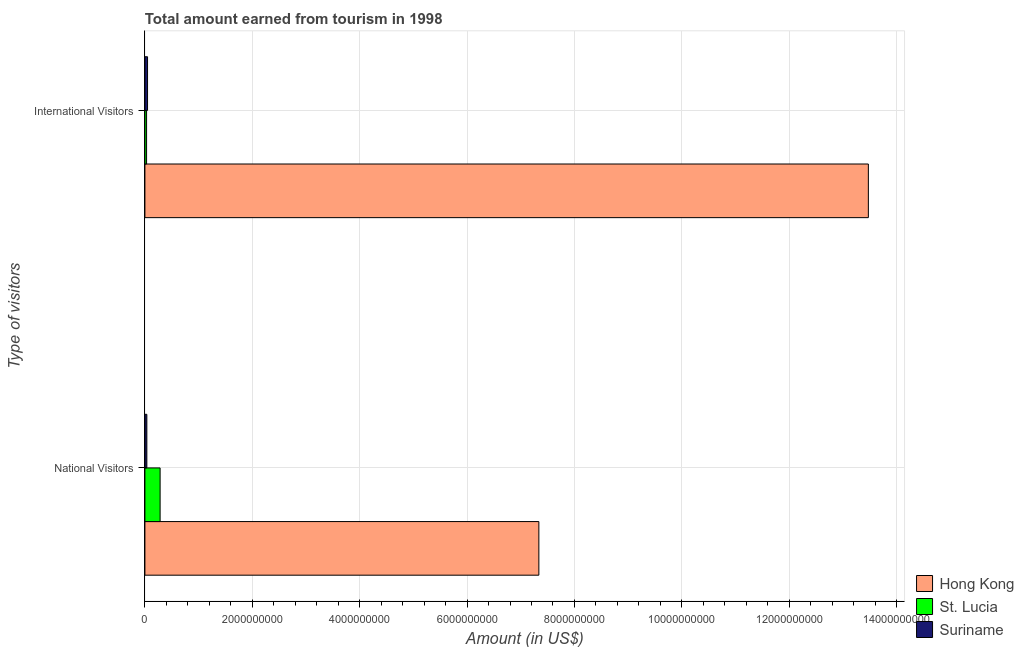Are the number of bars per tick equal to the number of legend labels?
Make the answer very short. Yes. How many bars are there on the 1st tick from the bottom?
Provide a short and direct response. 3. What is the label of the 2nd group of bars from the top?
Provide a succinct answer. National Visitors. What is the amount earned from national visitors in St. Lucia?
Keep it short and to the point. 2.83e+08. Across all countries, what is the maximum amount earned from international visitors?
Your answer should be compact. 1.35e+1. Across all countries, what is the minimum amount earned from national visitors?
Offer a very short reply. 3.60e+07. In which country was the amount earned from national visitors maximum?
Provide a short and direct response. Hong Kong. In which country was the amount earned from national visitors minimum?
Keep it short and to the point. Suriname. What is the total amount earned from international visitors in the graph?
Make the answer very short. 1.36e+1. What is the difference between the amount earned from international visitors in Suriname and that in St. Lucia?
Provide a succinct answer. 1.80e+07. What is the difference between the amount earned from international visitors in St. Lucia and the amount earned from national visitors in Hong Kong?
Give a very brief answer. -7.31e+09. What is the average amount earned from international visitors per country?
Your answer should be compact. 4.52e+09. What is the difference between the amount earned from national visitors and amount earned from international visitors in Suriname?
Provide a succinct answer. -1.30e+07. What is the ratio of the amount earned from international visitors in Suriname to that in Hong Kong?
Make the answer very short. 0. Is the amount earned from international visitors in Suriname less than that in Hong Kong?
Offer a terse response. Yes. What does the 2nd bar from the top in National Visitors represents?
Your answer should be compact. St. Lucia. What does the 2nd bar from the bottom in National Visitors represents?
Your answer should be very brief. St. Lucia. Are all the bars in the graph horizontal?
Keep it short and to the point. Yes. How many countries are there in the graph?
Keep it short and to the point. 3. What is the difference between two consecutive major ticks on the X-axis?
Your answer should be very brief. 2.00e+09. What is the title of the graph?
Your response must be concise. Total amount earned from tourism in 1998. What is the label or title of the X-axis?
Offer a very short reply. Amount (in US$). What is the label or title of the Y-axis?
Ensure brevity in your answer.  Type of visitors. What is the Amount (in US$) in Hong Kong in National Visitors?
Ensure brevity in your answer.  7.34e+09. What is the Amount (in US$) of St. Lucia in National Visitors?
Your answer should be compact. 2.83e+08. What is the Amount (in US$) in Suriname in National Visitors?
Keep it short and to the point. 3.60e+07. What is the Amount (in US$) of Hong Kong in International Visitors?
Your response must be concise. 1.35e+1. What is the Amount (in US$) of St. Lucia in International Visitors?
Provide a succinct answer. 3.10e+07. What is the Amount (in US$) in Suriname in International Visitors?
Your response must be concise. 4.90e+07. Across all Type of visitors, what is the maximum Amount (in US$) in Hong Kong?
Your answer should be compact. 1.35e+1. Across all Type of visitors, what is the maximum Amount (in US$) of St. Lucia?
Your answer should be compact. 2.83e+08. Across all Type of visitors, what is the maximum Amount (in US$) of Suriname?
Offer a very short reply. 4.90e+07. Across all Type of visitors, what is the minimum Amount (in US$) of Hong Kong?
Keep it short and to the point. 7.34e+09. Across all Type of visitors, what is the minimum Amount (in US$) in St. Lucia?
Provide a succinct answer. 3.10e+07. Across all Type of visitors, what is the minimum Amount (in US$) of Suriname?
Your response must be concise. 3.60e+07. What is the total Amount (in US$) in Hong Kong in the graph?
Your answer should be very brief. 2.08e+1. What is the total Amount (in US$) in St. Lucia in the graph?
Offer a terse response. 3.14e+08. What is the total Amount (in US$) in Suriname in the graph?
Offer a very short reply. 8.50e+07. What is the difference between the Amount (in US$) in Hong Kong in National Visitors and that in International Visitors?
Your response must be concise. -6.14e+09. What is the difference between the Amount (in US$) of St. Lucia in National Visitors and that in International Visitors?
Offer a terse response. 2.52e+08. What is the difference between the Amount (in US$) of Suriname in National Visitors and that in International Visitors?
Provide a succinct answer. -1.30e+07. What is the difference between the Amount (in US$) in Hong Kong in National Visitors and the Amount (in US$) in St. Lucia in International Visitors?
Ensure brevity in your answer.  7.31e+09. What is the difference between the Amount (in US$) of Hong Kong in National Visitors and the Amount (in US$) of Suriname in International Visitors?
Give a very brief answer. 7.29e+09. What is the difference between the Amount (in US$) in St. Lucia in National Visitors and the Amount (in US$) in Suriname in International Visitors?
Ensure brevity in your answer.  2.34e+08. What is the average Amount (in US$) of Hong Kong per Type of visitors?
Offer a terse response. 1.04e+1. What is the average Amount (in US$) in St. Lucia per Type of visitors?
Your answer should be compact. 1.57e+08. What is the average Amount (in US$) in Suriname per Type of visitors?
Offer a very short reply. 4.25e+07. What is the difference between the Amount (in US$) of Hong Kong and Amount (in US$) of St. Lucia in National Visitors?
Offer a very short reply. 7.05e+09. What is the difference between the Amount (in US$) of Hong Kong and Amount (in US$) of Suriname in National Visitors?
Give a very brief answer. 7.30e+09. What is the difference between the Amount (in US$) in St. Lucia and Amount (in US$) in Suriname in National Visitors?
Keep it short and to the point. 2.47e+08. What is the difference between the Amount (in US$) of Hong Kong and Amount (in US$) of St. Lucia in International Visitors?
Keep it short and to the point. 1.34e+1. What is the difference between the Amount (in US$) in Hong Kong and Amount (in US$) in Suriname in International Visitors?
Your response must be concise. 1.34e+1. What is the difference between the Amount (in US$) in St. Lucia and Amount (in US$) in Suriname in International Visitors?
Offer a very short reply. -1.80e+07. What is the ratio of the Amount (in US$) in Hong Kong in National Visitors to that in International Visitors?
Keep it short and to the point. 0.54. What is the ratio of the Amount (in US$) of St. Lucia in National Visitors to that in International Visitors?
Give a very brief answer. 9.13. What is the ratio of the Amount (in US$) of Suriname in National Visitors to that in International Visitors?
Provide a short and direct response. 0.73. What is the difference between the highest and the second highest Amount (in US$) in Hong Kong?
Provide a succinct answer. 6.14e+09. What is the difference between the highest and the second highest Amount (in US$) in St. Lucia?
Keep it short and to the point. 2.52e+08. What is the difference between the highest and the second highest Amount (in US$) of Suriname?
Provide a short and direct response. 1.30e+07. What is the difference between the highest and the lowest Amount (in US$) in Hong Kong?
Make the answer very short. 6.14e+09. What is the difference between the highest and the lowest Amount (in US$) in St. Lucia?
Provide a succinct answer. 2.52e+08. What is the difference between the highest and the lowest Amount (in US$) of Suriname?
Keep it short and to the point. 1.30e+07. 